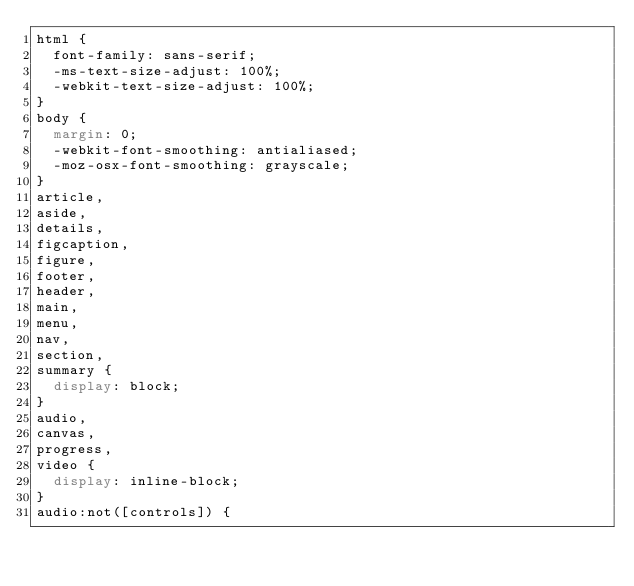<code> <loc_0><loc_0><loc_500><loc_500><_CSS_>html {
	font-family: sans-serif;
	-ms-text-size-adjust: 100%;
	-webkit-text-size-adjust: 100%;
}
body {
	margin: 0;
	-webkit-font-smoothing: antialiased;
	-moz-osx-font-smoothing: grayscale;
}
article,
aside,
details,
figcaption,
figure,
footer,
header,
main,
menu,
nav,
section,
summary {
	display: block;
}
audio,
canvas,
progress,
video {
	display: inline-block;
}
audio:not([controls]) {</code> 